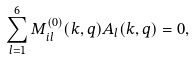Convert formula to latex. <formula><loc_0><loc_0><loc_500><loc_500>\sum _ { l = 1 } ^ { 6 } M ^ { ( 0 ) } _ { i l } ( k , { q } ) A _ { l } ( k , { q } ) = 0 ,</formula> 